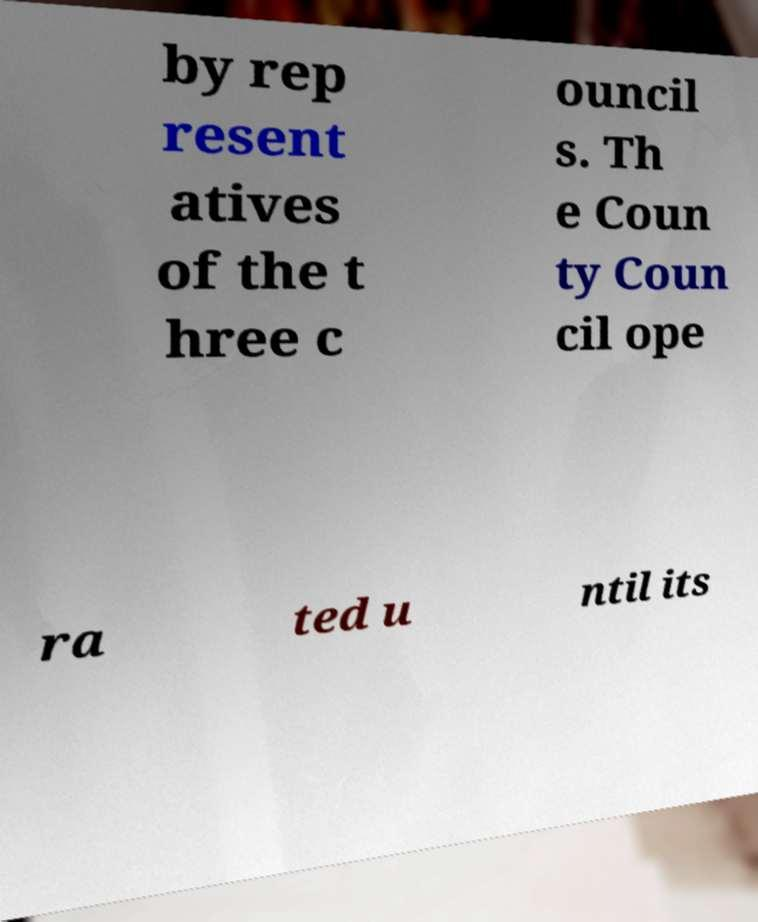There's text embedded in this image that I need extracted. Can you transcribe it verbatim? by rep resent atives of the t hree c ouncil s. Th e Coun ty Coun cil ope ra ted u ntil its 